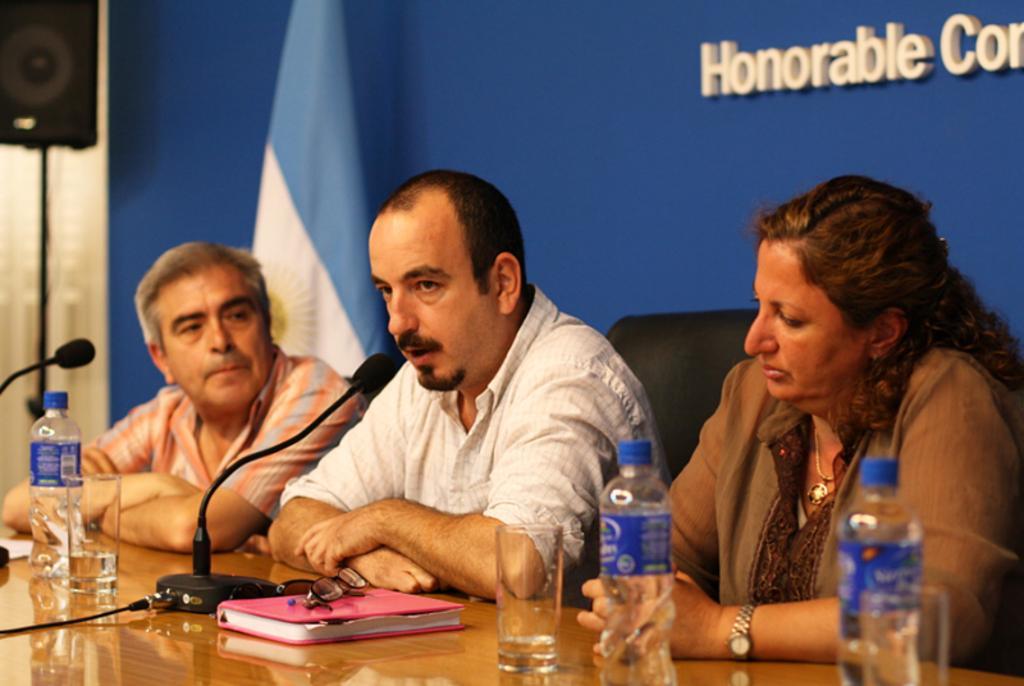Can you describe this image briefly? In the background we can see a flag and a board. On the left side of the picture we can see a stand and a speaker. We can see the people. In this picture we can see a table and on a table we can see microphones, water glasses, bottles and we can see spectacles on a diary. 